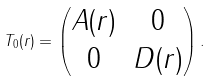Convert formula to latex. <formula><loc_0><loc_0><loc_500><loc_500>T _ { 0 } ( r ) = \begin{pmatrix} A ( r ) & 0 \\ 0 & D ( r ) \end{pmatrix} .</formula> 